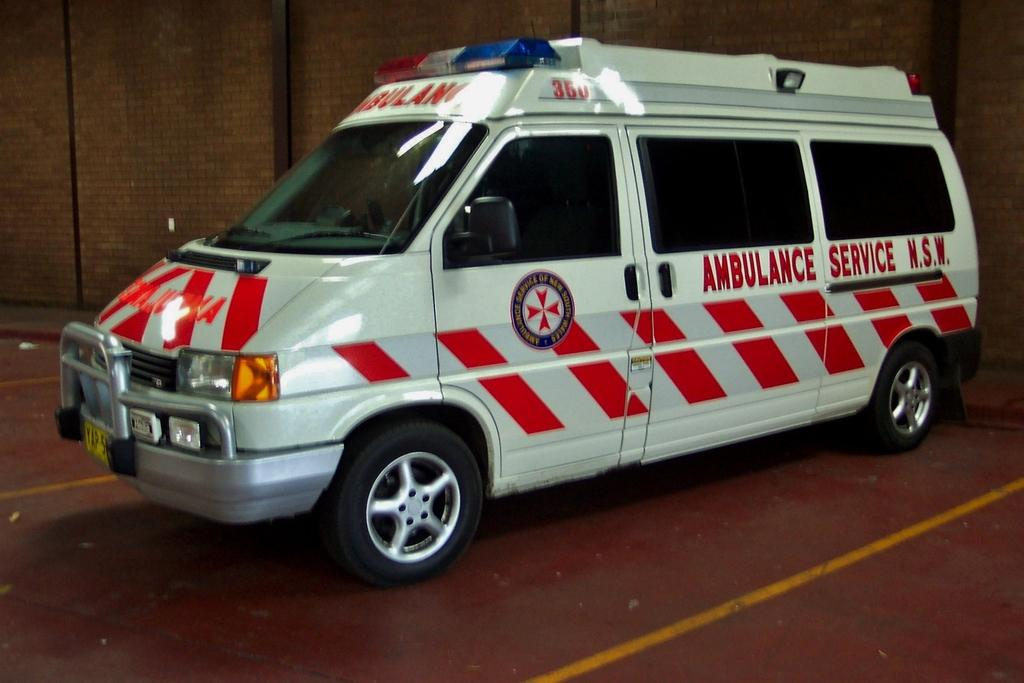<image>
Write a terse but informative summary of the picture. An Ambulance Service N.S.W. van is parked in a parking space. 